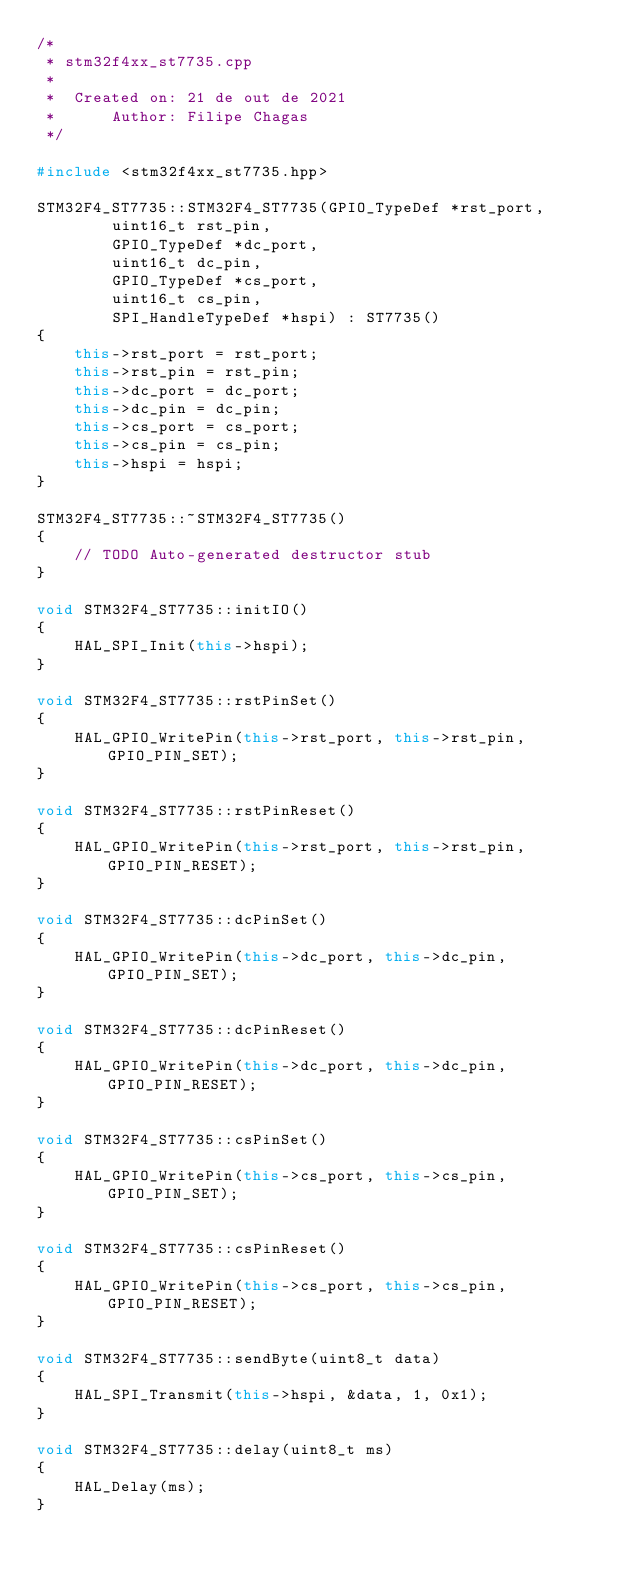<code> <loc_0><loc_0><loc_500><loc_500><_C++_>/*
 * stm32f4xx_st7735.cpp
 *
 *  Created on: 21 de out de 2021
 *      Author: Filipe Chagas
 */

#include <stm32f4xx_st7735.hpp>

STM32F4_ST7735::STM32F4_ST7735(GPIO_TypeDef *rst_port,
		uint16_t rst_pin,
		GPIO_TypeDef *dc_port,
		uint16_t dc_pin,
		GPIO_TypeDef *cs_port,
		uint16_t cs_pin,
		SPI_HandleTypeDef *hspi) : ST7735()
{
	this->rst_port = rst_port;
	this->rst_pin = rst_pin;
	this->dc_port = dc_port;
	this->dc_pin = dc_pin;
	this->cs_port = cs_port;
	this->cs_pin = cs_pin;
	this->hspi = hspi;
}

STM32F4_ST7735::~STM32F4_ST7735()
{
	// TODO Auto-generated destructor stub
}

void STM32F4_ST7735::initIO()
{
	HAL_SPI_Init(this->hspi);
}

void STM32F4_ST7735::rstPinSet()
{
	HAL_GPIO_WritePin(this->rst_port, this->rst_pin, GPIO_PIN_SET);
}

void STM32F4_ST7735::rstPinReset()
{
	HAL_GPIO_WritePin(this->rst_port, this->rst_pin, GPIO_PIN_RESET);
}

void STM32F4_ST7735::dcPinSet()
{
	HAL_GPIO_WritePin(this->dc_port, this->dc_pin, GPIO_PIN_SET);
}

void STM32F4_ST7735::dcPinReset()
{
	HAL_GPIO_WritePin(this->dc_port, this->dc_pin, GPIO_PIN_RESET);
}

void STM32F4_ST7735::csPinSet()
{
	HAL_GPIO_WritePin(this->cs_port, this->cs_pin, GPIO_PIN_SET);
}

void STM32F4_ST7735::csPinReset()
{
	HAL_GPIO_WritePin(this->cs_port, this->cs_pin, GPIO_PIN_RESET);
}

void STM32F4_ST7735::sendByte(uint8_t data)
{
	HAL_SPI_Transmit(this->hspi, &data, 1, 0x1);
}

void STM32F4_ST7735::delay(uint8_t ms)
{
	HAL_Delay(ms);
}
</code> 